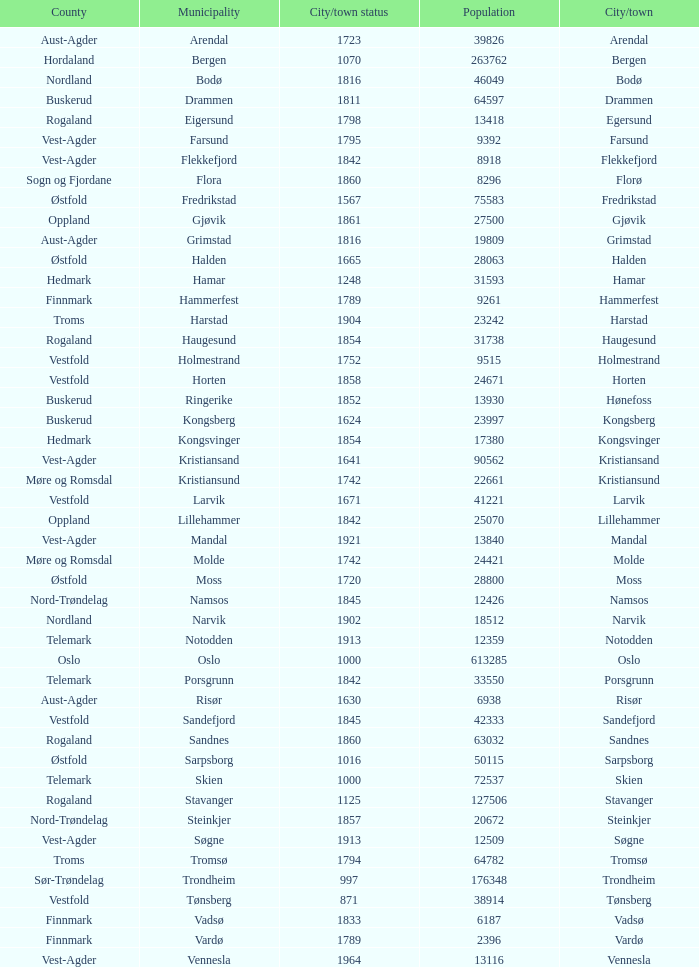What is the total population in the city/town of Arendal? 1.0. 